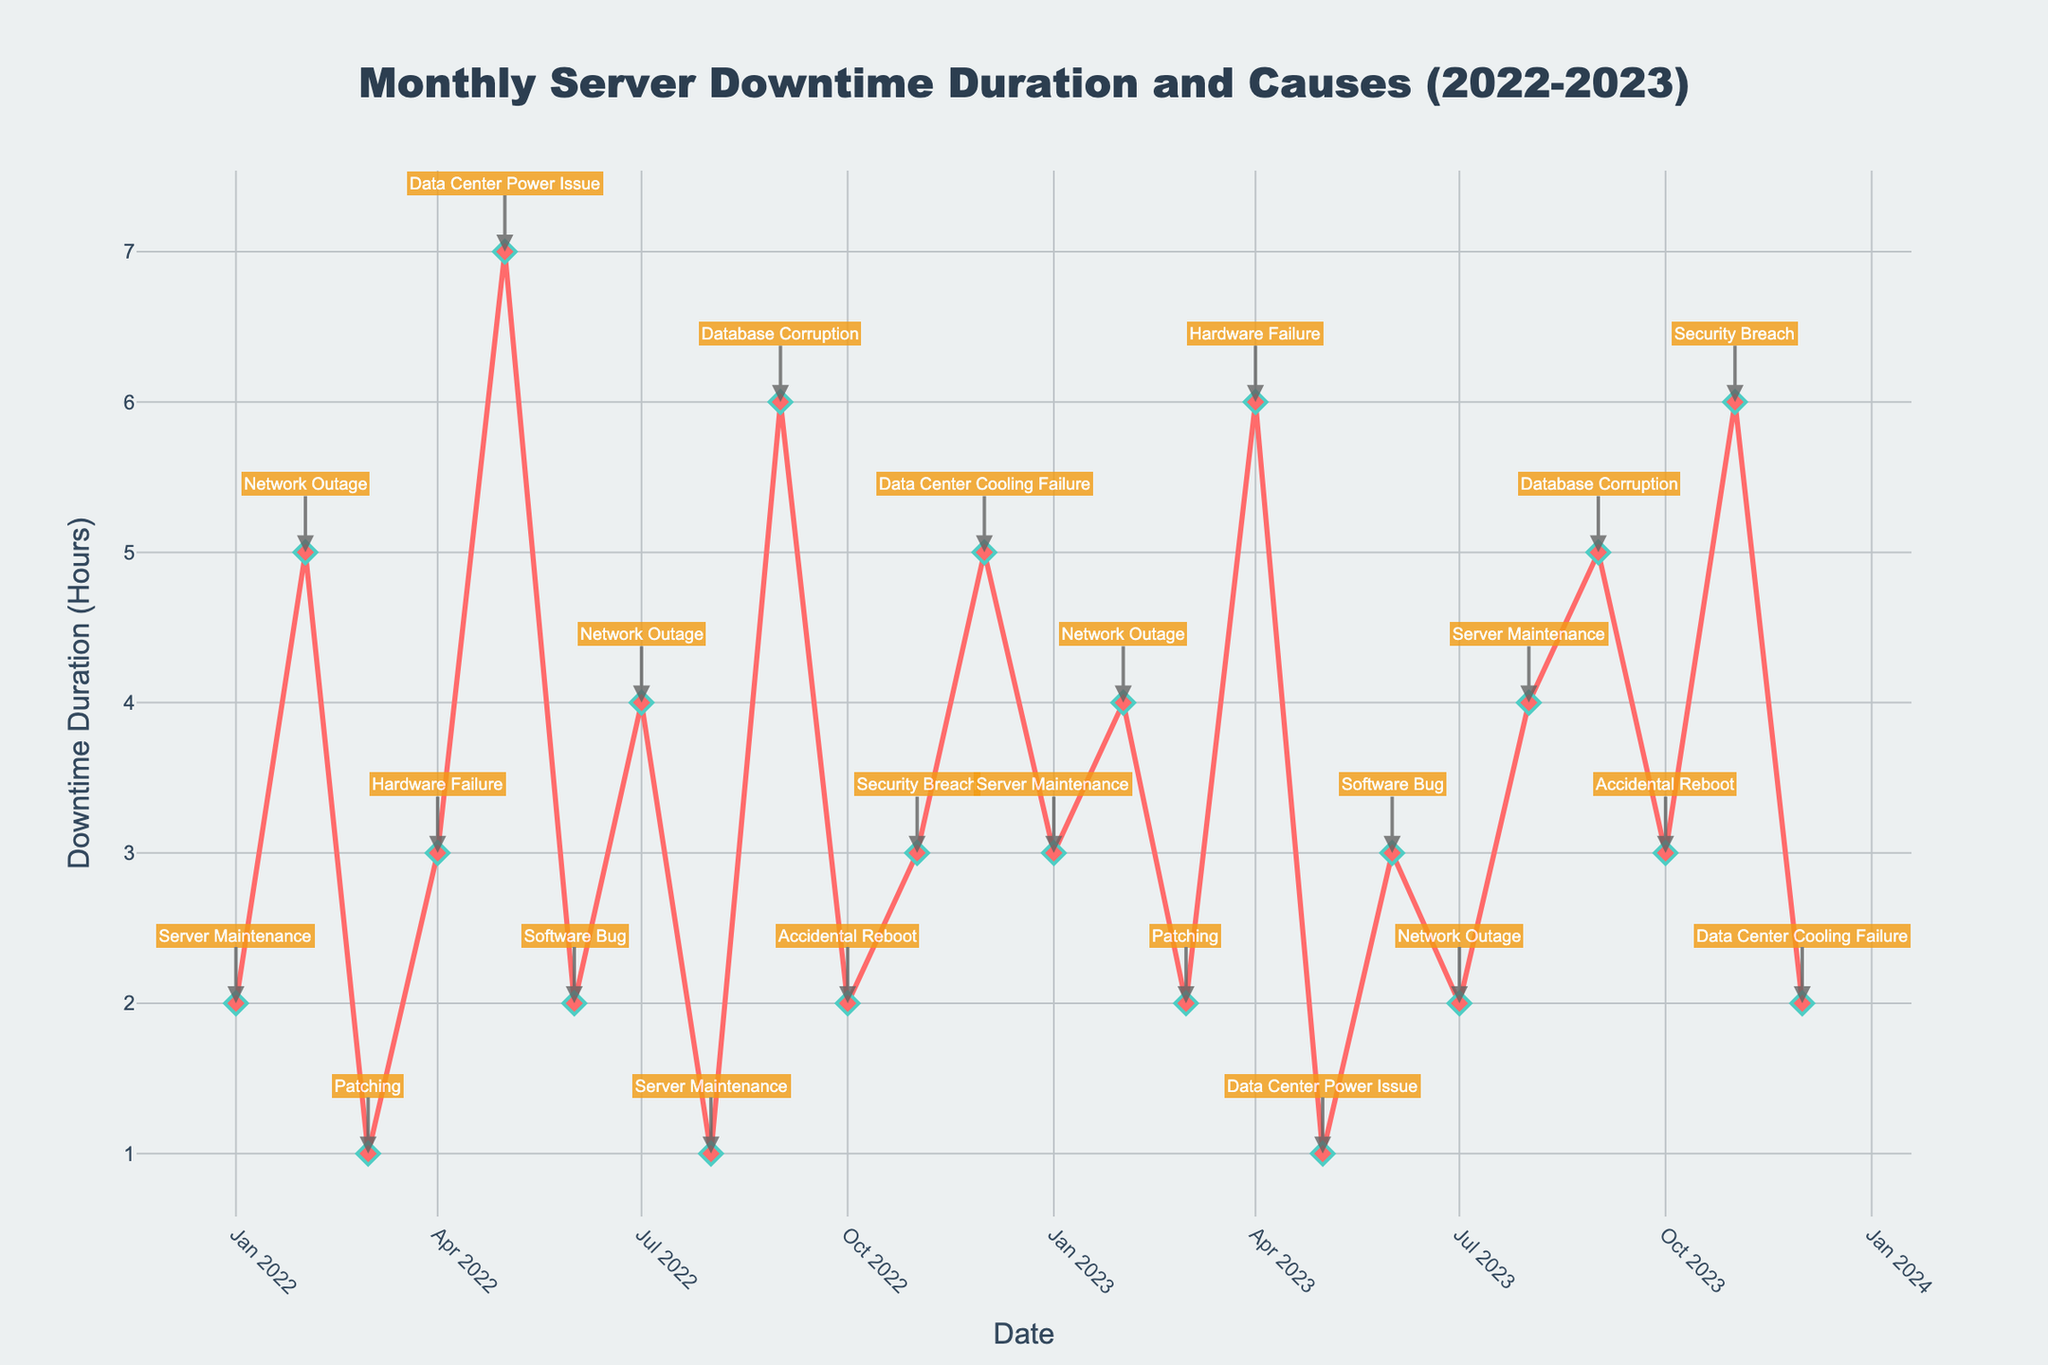What's the general trend of the downtime duration over the two years? Observing the line representing downtime duration, it generally fluctuates without a clear increasing or decreasing trend. Both years show months with high and low downtime durations, indicating no consistent trend over the two-year period.
Answer: No clear trend Which month had the highest downtime duration and for what cause? The plot shows the highest peak at May 2022 with a downtime duration of 7 hours. The corresponding annotation reveals that the cause was 'Data Center Power Issue'.
Answer: May 2022, Data Center Power Issue What is the longest duration for a Network Outage over the two years? Checking the peaks annotated as 'Network Outage', the highest downtime duration is 5 hours seen in February 2022.
Answer: 5 hours Which cause appeared the most frequently over the two years? By counting the annotations, 'Network Outage' appears four times (February 2022, July 2022, February 2023, July 2023), which is the most frequent compared to other causes.
Answer: Network Outage How many months had a downtime duration of exactly 2 hours? The plot shows data points at 2 hours for January 2022, June 2022, October 2022, March 2023, July 2023, and December 2023, totaling 6 months.
Answer: 6 months Compare the downtime duration in July 2022 with that in July 2023. Which one had more downtime? By examining the data points, July 2022 had a downtime duration of 4 hours, while July 2023 had 2 hours. Thus, July 2022 had more downtime.
Answer: July 2022 What was the total downtime duration due to Server Maintenance over the two years? Summing the downtime durations for 'Server Maintenance' (January 2022: 2 hours, August 2022: 1 hour, January 2023: 3 hours, August 2023: 4 hours), the total is 2 + 1 + 3 + 4 = 10 hours.
Answer: 10 hours How does the downtime duration in January 2022 compare to January 2023? Looking at the plot, January 2022 had 2 hours of downtime, while January 2023 had 3 hours. Therefore, January 2023 had 1 hour more downtime than January 2022.
Answer: January 2023 had more What is the average monthly downtime duration for 2022? Summing the monthly downtime durations for 2022 (2, 5, 1, 3, 7, 2, 4, 1, 6, 2, 3, 5) gives 41 hours. Dividing by 12 months, the average is 41/12 ≈ 3.42 hours.
Answer: ~3.42 hours 